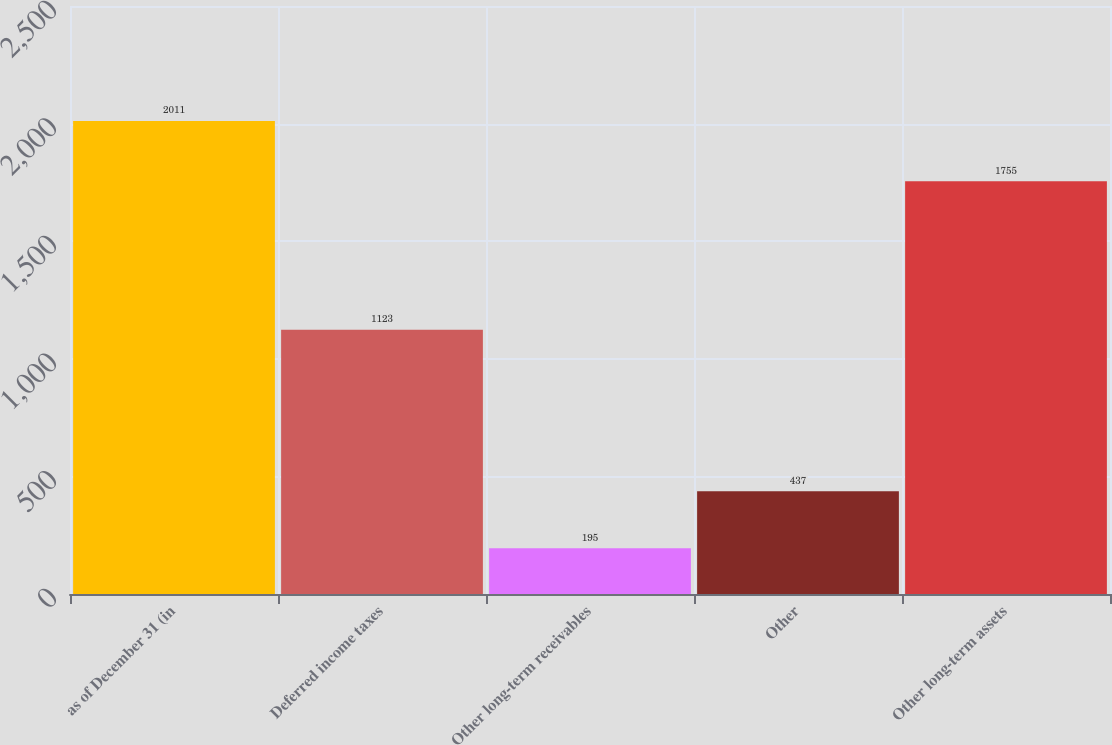Convert chart. <chart><loc_0><loc_0><loc_500><loc_500><bar_chart><fcel>as of December 31 (in<fcel>Deferred income taxes<fcel>Other long-term receivables<fcel>Other<fcel>Other long-term assets<nl><fcel>2011<fcel>1123<fcel>195<fcel>437<fcel>1755<nl></chart> 